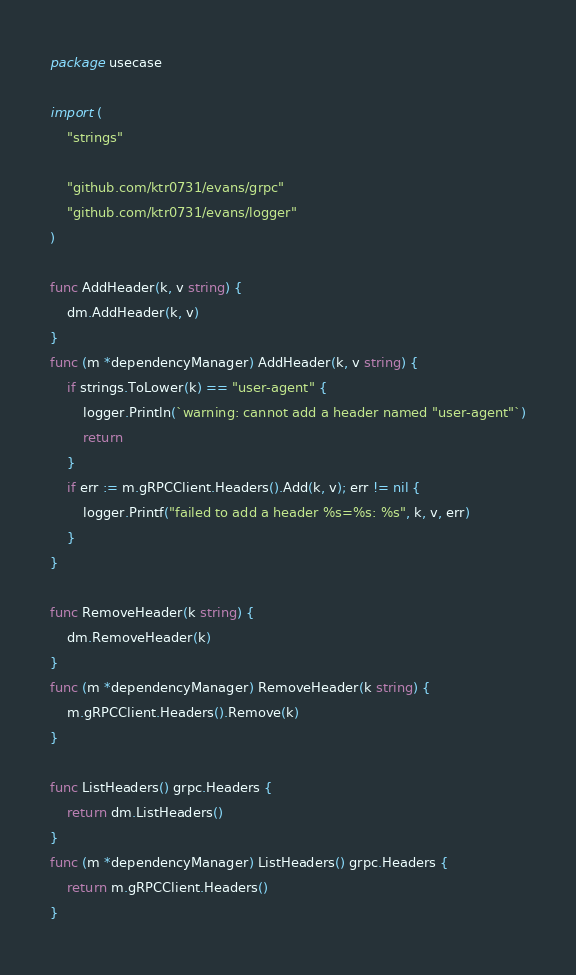<code> <loc_0><loc_0><loc_500><loc_500><_Go_>package usecase

import (
	"strings"

	"github.com/ktr0731/evans/grpc"
	"github.com/ktr0731/evans/logger"
)

func AddHeader(k, v string) {
	dm.AddHeader(k, v)
}
func (m *dependencyManager) AddHeader(k, v string) {
	if strings.ToLower(k) == "user-agent" {
		logger.Println(`warning: cannot add a header named "user-agent"`)
		return
	}
	if err := m.gRPCClient.Headers().Add(k, v); err != nil {
		logger.Printf("failed to add a header %s=%s: %s", k, v, err)
	}
}

func RemoveHeader(k string) {
	dm.RemoveHeader(k)
}
func (m *dependencyManager) RemoveHeader(k string) {
	m.gRPCClient.Headers().Remove(k)
}

func ListHeaders() grpc.Headers {
	return dm.ListHeaders()
}
func (m *dependencyManager) ListHeaders() grpc.Headers {
	return m.gRPCClient.Headers()
}
</code> 